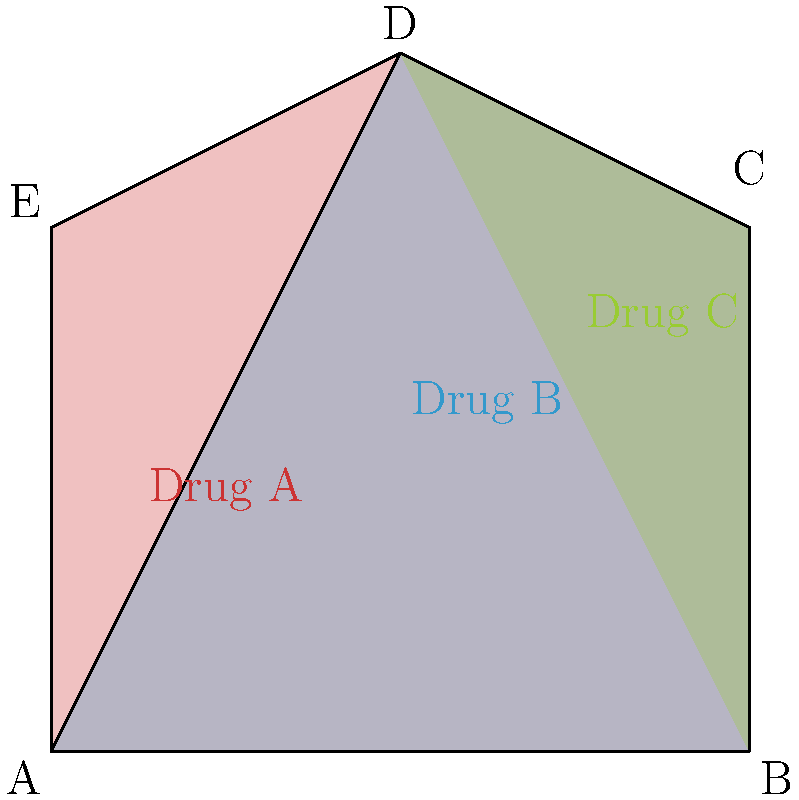In a study of drug interactions, the polygonal region ABCDE represents the interaction zones of three medications. The coordinates of the vertices are A(0,0), B(4,0), C(4,3), D(2,4), and E(0,3). Drug A covers the entire region ABCDE, Drug B covers ABCD, and Drug C covers BCD. Calculate the total area where all three drugs interact simultaneously. Let's approach this step-by-step:

1) First, we need to find the area of triangle BCD, as this is the region where all three drugs interact.

2) To calculate the area of triangle BCD, we can use the formula:
   Area = $\frac{1}{2}|x_1(y_2 - y_3) + x_2(y_3 - y_1) + x_3(y_1 - y_2)|$

   Where $(x_1,y_1)$, $(x_2,y_2)$, and $(x_3,y_3)$ are the coordinates of the three points.

3) Substituting the coordinates:
   B(4,0), C(4,3), D(2,4)

4) Applying the formula:
   Area = $\frac{1}{2}|4(3 - 4) + 4(4 - 0) + 2(0 - 3)|$
        = $\frac{1}{2}|4(-1) + 4(4) + 2(-3)|$
        = $\frac{1}{2}|-4 + 16 - 6|$
        = $\frac{1}{2}|6|$
        = $\frac{1}{2}(6)$
        = 3

5) Therefore, the area where all three drugs interact is 3 square units.
Answer: 3 square units 